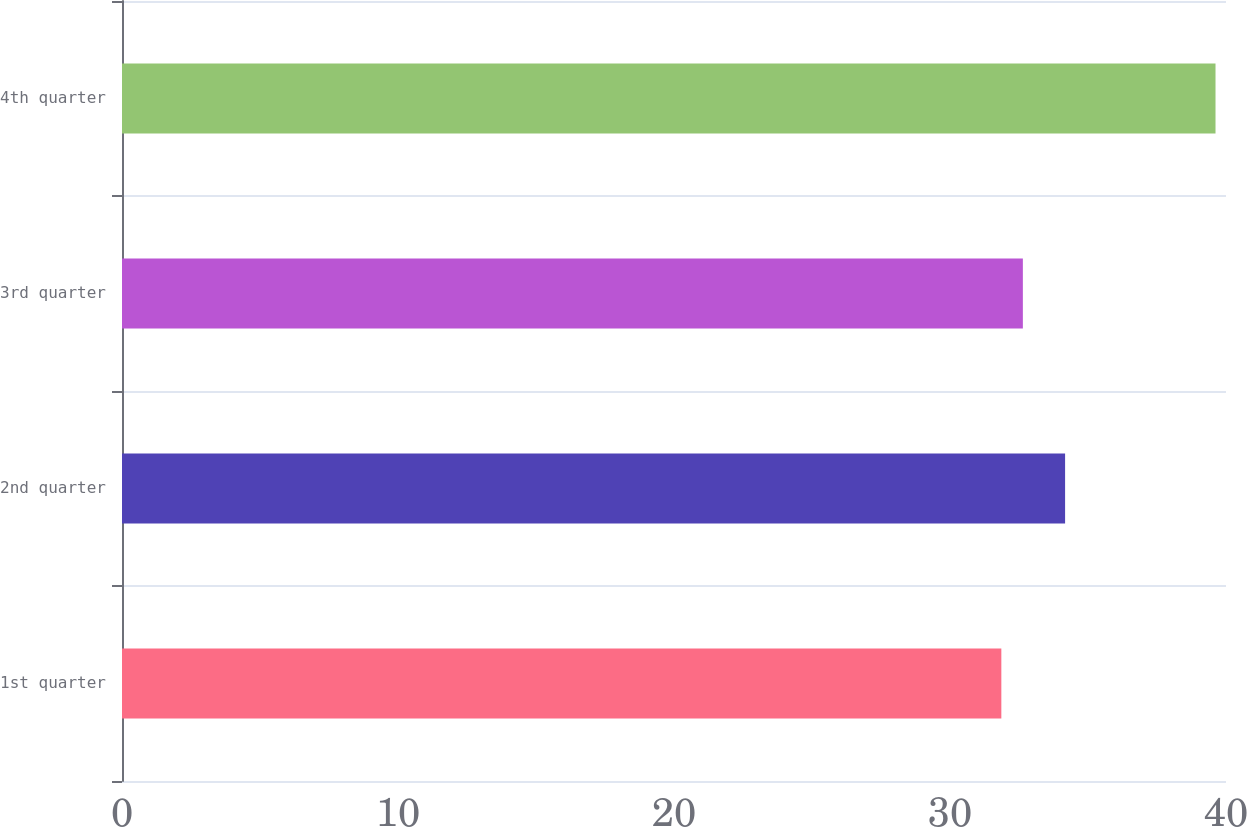<chart> <loc_0><loc_0><loc_500><loc_500><bar_chart><fcel>1st quarter<fcel>2nd quarter<fcel>3rd quarter<fcel>4th quarter<nl><fcel>31.86<fcel>34.17<fcel>32.64<fcel>39.62<nl></chart> 